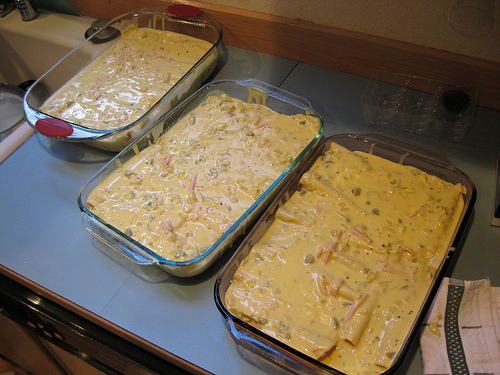<image>
Can you confirm if the food is in the baking tray? No. The food is not contained within the baking tray. These objects have a different spatial relationship. 